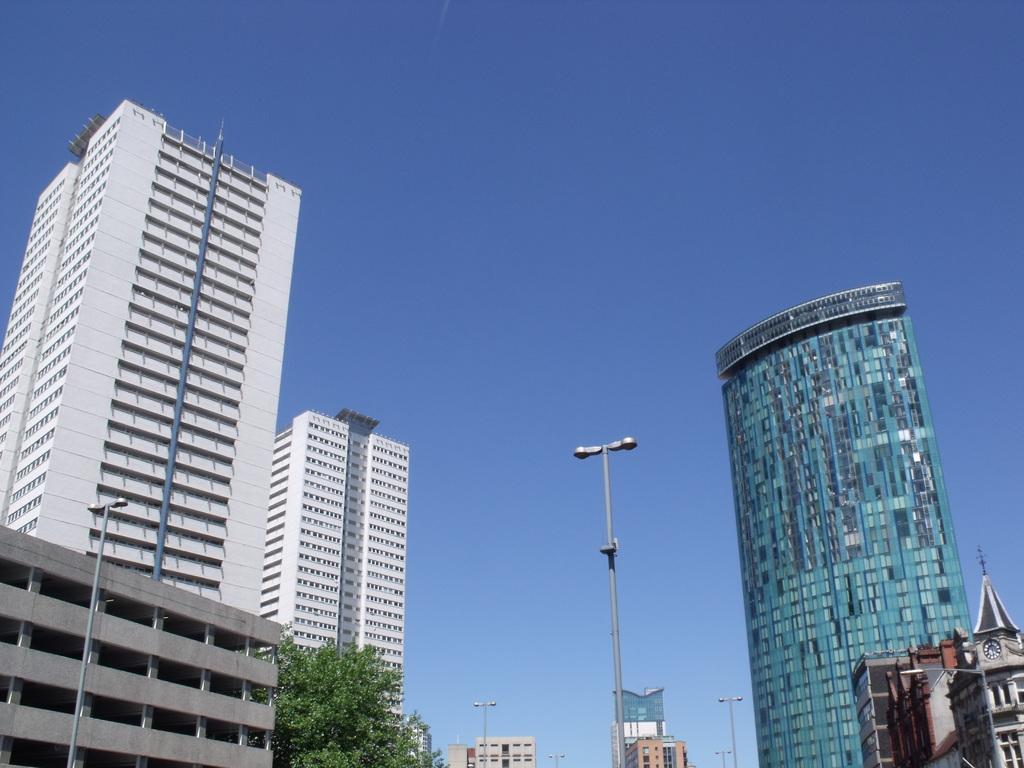Could you give a brief overview of what you see in this image? In this picture I can see some buildings and trees. 